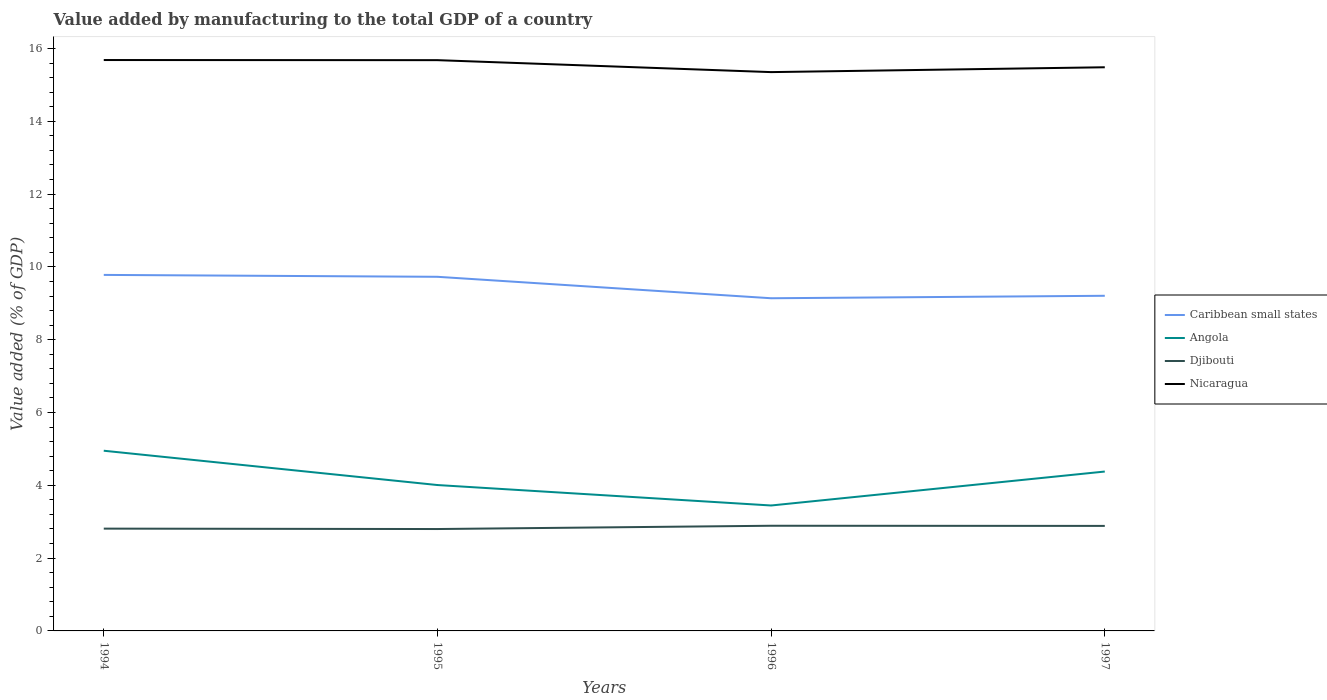Does the line corresponding to Nicaragua intersect with the line corresponding to Djibouti?
Make the answer very short. No. Is the number of lines equal to the number of legend labels?
Keep it short and to the point. Yes. Across all years, what is the maximum value added by manufacturing to the total GDP in Nicaragua?
Provide a succinct answer. 15.35. What is the total value added by manufacturing to the total GDP in Nicaragua in the graph?
Give a very brief answer. 0. What is the difference between the highest and the second highest value added by manufacturing to the total GDP in Angola?
Keep it short and to the point. 1.5. What is the difference between the highest and the lowest value added by manufacturing to the total GDP in Angola?
Give a very brief answer. 2. Is the value added by manufacturing to the total GDP in Nicaragua strictly greater than the value added by manufacturing to the total GDP in Angola over the years?
Keep it short and to the point. No. What is the difference between two consecutive major ticks on the Y-axis?
Offer a very short reply. 2. Are the values on the major ticks of Y-axis written in scientific E-notation?
Your response must be concise. No. Does the graph contain grids?
Keep it short and to the point. No. Where does the legend appear in the graph?
Give a very brief answer. Center right. How many legend labels are there?
Keep it short and to the point. 4. How are the legend labels stacked?
Your answer should be compact. Vertical. What is the title of the graph?
Provide a succinct answer. Value added by manufacturing to the total GDP of a country. What is the label or title of the Y-axis?
Make the answer very short. Value added (% of GDP). What is the Value added (% of GDP) of Caribbean small states in 1994?
Give a very brief answer. 9.78. What is the Value added (% of GDP) of Angola in 1994?
Your answer should be very brief. 4.95. What is the Value added (% of GDP) of Djibouti in 1994?
Offer a very short reply. 2.81. What is the Value added (% of GDP) in Nicaragua in 1994?
Your answer should be very brief. 15.68. What is the Value added (% of GDP) in Caribbean small states in 1995?
Your answer should be compact. 9.73. What is the Value added (% of GDP) in Angola in 1995?
Your response must be concise. 4.01. What is the Value added (% of GDP) in Djibouti in 1995?
Keep it short and to the point. 2.8. What is the Value added (% of GDP) in Nicaragua in 1995?
Ensure brevity in your answer.  15.68. What is the Value added (% of GDP) in Caribbean small states in 1996?
Your answer should be very brief. 9.14. What is the Value added (% of GDP) in Angola in 1996?
Make the answer very short. 3.45. What is the Value added (% of GDP) in Djibouti in 1996?
Your response must be concise. 2.89. What is the Value added (% of GDP) in Nicaragua in 1996?
Offer a terse response. 15.35. What is the Value added (% of GDP) of Caribbean small states in 1997?
Your answer should be very brief. 9.21. What is the Value added (% of GDP) of Angola in 1997?
Your answer should be compact. 4.38. What is the Value added (% of GDP) of Djibouti in 1997?
Provide a short and direct response. 2.89. What is the Value added (% of GDP) in Nicaragua in 1997?
Provide a short and direct response. 15.48. Across all years, what is the maximum Value added (% of GDP) of Caribbean small states?
Offer a very short reply. 9.78. Across all years, what is the maximum Value added (% of GDP) in Angola?
Provide a short and direct response. 4.95. Across all years, what is the maximum Value added (% of GDP) in Djibouti?
Offer a very short reply. 2.89. Across all years, what is the maximum Value added (% of GDP) of Nicaragua?
Provide a short and direct response. 15.68. Across all years, what is the minimum Value added (% of GDP) in Caribbean small states?
Provide a short and direct response. 9.14. Across all years, what is the minimum Value added (% of GDP) in Angola?
Offer a terse response. 3.45. Across all years, what is the minimum Value added (% of GDP) of Djibouti?
Offer a very short reply. 2.8. Across all years, what is the minimum Value added (% of GDP) in Nicaragua?
Provide a short and direct response. 15.35. What is the total Value added (% of GDP) of Caribbean small states in the graph?
Make the answer very short. 37.85. What is the total Value added (% of GDP) of Angola in the graph?
Your response must be concise. 16.78. What is the total Value added (% of GDP) of Djibouti in the graph?
Provide a short and direct response. 11.38. What is the total Value added (% of GDP) of Nicaragua in the graph?
Provide a succinct answer. 62.2. What is the difference between the Value added (% of GDP) in Caribbean small states in 1994 and that in 1995?
Your answer should be compact. 0.05. What is the difference between the Value added (% of GDP) in Angola in 1994 and that in 1995?
Make the answer very short. 0.94. What is the difference between the Value added (% of GDP) in Djibouti in 1994 and that in 1995?
Provide a succinct answer. 0.01. What is the difference between the Value added (% of GDP) of Nicaragua in 1994 and that in 1995?
Ensure brevity in your answer.  0. What is the difference between the Value added (% of GDP) in Caribbean small states in 1994 and that in 1996?
Ensure brevity in your answer.  0.64. What is the difference between the Value added (% of GDP) in Angola in 1994 and that in 1996?
Keep it short and to the point. 1.5. What is the difference between the Value added (% of GDP) of Djibouti in 1994 and that in 1996?
Provide a short and direct response. -0.08. What is the difference between the Value added (% of GDP) of Nicaragua in 1994 and that in 1996?
Keep it short and to the point. 0.33. What is the difference between the Value added (% of GDP) in Caribbean small states in 1994 and that in 1997?
Your answer should be compact. 0.57. What is the difference between the Value added (% of GDP) in Angola in 1994 and that in 1997?
Your answer should be very brief. 0.57. What is the difference between the Value added (% of GDP) of Djibouti in 1994 and that in 1997?
Make the answer very short. -0.07. What is the difference between the Value added (% of GDP) in Nicaragua in 1994 and that in 1997?
Your answer should be compact. 0.2. What is the difference between the Value added (% of GDP) in Caribbean small states in 1995 and that in 1996?
Your answer should be very brief. 0.59. What is the difference between the Value added (% of GDP) in Angola in 1995 and that in 1996?
Ensure brevity in your answer.  0.56. What is the difference between the Value added (% of GDP) in Djibouti in 1995 and that in 1996?
Ensure brevity in your answer.  -0.09. What is the difference between the Value added (% of GDP) in Nicaragua in 1995 and that in 1996?
Offer a very short reply. 0.33. What is the difference between the Value added (% of GDP) of Caribbean small states in 1995 and that in 1997?
Provide a succinct answer. 0.52. What is the difference between the Value added (% of GDP) in Angola in 1995 and that in 1997?
Give a very brief answer. -0.37. What is the difference between the Value added (% of GDP) of Djibouti in 1995 and that in 1997?
Keep it short and to the point. -0.09. What is the difference between the Value added (% of GDP) of Nicaragua in 1995 and that in 1997?
Your response must be concise. 0.2. What is the difference between the Value added (% of GDP) of Caribbean small states in 1996 and that in 1997?
Your answer should be very brief. -0.07. What is the difference between the Value added (% of GDP) of Angola in 1996 and that in 1997?
Your answer should be compact. -0.93. What is the difference between the Value added (% of GDP) of Djibouti in 1996 and that in 1997?
Your response must be concise. 0. What is the difference between the Value added (% of GDP) of Nicaragua in 1996 and that in 1997?
Provide a succinct answer. -0.13. What is the difference between the Value added (% of GDP) of Caribbean small states in 1994 and the Value added (% of GDP) of Angola in 1995?
Give a very brief answer. 5.77. What is the difference between the Value added (% of GDP) of Caribbean small states in 1994 and the Value added (% of GDP) of Djibouti in 1995?
Your answer should be very brief. 6.98. What is the difference between the Value added (% of GDP) of Caribbean small states in 1994 and the Value added (% of GDP) of Nicaragua in 1995?
Keep it short and to the point. -5.9. What is the difference between the Value added (% of GDP) of Angola in 1994 and the Value added (% of GDP) of Djibouti in 1995?
Offer a terse response. 2.15. What is the difference between the Value added (% of GDP) in Angola in 1994 and the Value added (% of GDP) in Nicaragua in 1995?
Provide a succinct answer. -10.73. What is the difference between the Value added (% of GDP) of Djibouti in 1994 and the Value added (% of GDP) of Nicaragua in 1995?
Make the answer very short. -12.87. What is the difference between the Value added (% of GDP) of Caribbean small states in 1994 and the Value added (% of GDP) of Angola in 1996?
Your answer should be very brief. 6.33. What is the difference between the Value added (% of GDP) of Caribbean small states in 1994 and the Value added (% of GDP) of Djibouti in 1996?
Give a very brief answer. 6.89. What is the difference between the Value added (% of GDP) in Caribbean small states in 1994 and the Value added (% of GDP) in Nicaragua in 1996?
Your response must be concise. -5.57. What is the difference between the Value added (% of GDP) in Angola in 1994 and the Value added (% of GDP) in Djibouti in 1996?
Your answer should be compact. 2.06. What is the difference between the Value added (% of GDP) of Angola in 1994 and the Value added (% of GDP) of Nicaragua in 1996?
Keep it short and to the point. -10.4. What is the difference between the Value added (% of GDP) of Djibouti in 1994 and the Value added (% of GDP) of Nicaragua in 1996?
Keep it short and to the point. -12.54. What is the difference between the Value added (% of GDP) in Caribbean small states in 1994 and the Value added (% of GDP) in Angola in 1997?
Your answer should be very brief. 5.4. What is the difference between the Value added (% of GDP) of Caribbean small states in 1994 and the Value added (% of GDP) of Djibouti in 1997?
Provide a short and direct response. 6.89. What is the difference between the Value added (% of GDP) in Caribbean small states in 1994 and the Value added (% of GDP) in Nicaragua in 1997?
Offer a terse response. -5.7. What is the difference between the Value added (% of GDP) in Angola in 1994 and the Value added (% of GDP) in Djibouti in 1997?
Provide a succinct answer. 2.06. What is the difference between the Value added (% of GDP) in Angola in 1994 and the Value added (% of GDP) in Nicaragua in 1997?
Give a very brief answer. -10.53. What is the difference between the Value added (% of GDP) in Djibouti in 1994 and the Value added (% of GDP) in Nicaragua in 1997?
Make the answer very short. -12.67. What is the difference between the Value added (% of GDP) in Caribbean small states in 1995 and the Value added (% of GDP) in Angola in 1996?
Your response must be concise. 6.28. What is the difference between the Value added (% of GDP) of Caribbean small states in 1995 and the Value added (% of GDP) of Djibouti in 1996?
Offer a very short reply. 6.84. What is the difference between the Value added (% of GDP) of Caribbean small states in 1995 and the Value added (% of GDP) of Nicaragua in 1996?
Offer a very short reply. -5.62. What is the difference between the Value added (% of GDP) in Angola in 1995 and the Value added (% of GDP) in Djibouti in 1996?
Your answer should be compact. 1.12. What is the difference between the Value added (% of GDP) in Angola in 1995 and the Value added (% of GDP) in Nicaragua in 1996?
Your answer should be very brief. -11.34. What is the difference between the Value added (% of GDP) of Djibouti in 1995 and the Value added (% of GDP) of Nicaragua in 1996?
Your response must be concise. -12.55. What is the difference between the Value added (% of GDP) in Caribbean small states in 1995 and the Value added (% of GDP) in Angola in 1997?
Offer a very short reply. 5.35. What is the difference between the Value added (% of GDP) in Caribbean small states in 1995 and the Value added (% of GDP) in Djibouti in 1997?
Provide a succinct answer. 6.84. What is the difference between the Value added (% of GDP) of Caribbean small states in 1995 and the Value added (% of GDP) of Nicaragua in 1997?
Your answer should be compact. -5.76. What is the difference between the Value added (% of GDP) of Angola in 1995 and the Value added (% of GDP) of Djibouti in 1997?
Keep it short and to the point. 1.12. What is the difference between the Value added (% of GDP) in Angola in 1995 and the Value added (% of GDP) in Nicaragua in 1997?
Your response must be concise. -11.48. What is the difference between the Value added (% of GDP) of Djibouti in 1995 and the Value added (% of GDP) of Nicaragua in 1997?
Provide a short and direct response. -12.69. What is the difference between the Value added (% of GDP) in Caribbean small states in 1996 and the Value added (% of GDP) in Angola in 1997?
Your answer should be very brief. 4.76. What is the difference between the Value added (% of GDP) of Caribbean small states in 1996 and the Value added (% of GDP) of Djibouti in 1997?
Your answer should be compact. 6.25. What is the difference between the Value added (% of GDP) of Caribbean small states in 1996 and the Value added (% of GDP) of Nicaragua in 1997?
Make the answer very short. -6.35. What is the difference between the Value added (% of GDP) in Angola in 1996 and the Value added (% of GDP) in Djibouti in 1997?
Offer a very short reply. 0.56. What is the difference between the Value added (% of GDP) in Angola in 1996 and the Value added (% of GDP) in Nicaragua in 1997?
Your answer should be compact. -12.04. What is the difference between the Value added (% of GDP) of Djibouti in 1996 and the Value added (% of GDP) of Nicaragua in 1997?
Offer a very short reply. -12.6. What is the average Value added (% of GDP) in Caribbean small states per year?
Provide a succinct answer. 9.46. What is the average Value added (% of GDP) of Angola per year?
Provide a short and direct response. 4.2. What is the average Value added (% of GDP) of Djibouti per year?
Give a very brief answer. 2.85. What is the average Value added (% of GDP) in Nicaragua per year?
Provide a short and direct response. 15.55. In the year 1994, what is the difference between the Value added (% of GDP) of Caribbean small states and Value added (% of GDP) of Angola?
Your answer should be compact. 4.83. In the year 1994, what is the difference between the Value added (% of GDP) of Caribbean small states and Value added (% of GDP) of Djibouti?
Make the answer very short. 6.97. In the year 1994, what is the difference between the Value added (% of GDP) in Caribbean small states and Value added (% of GDP) in Nicaragua?
Your response must be concise. -5.9. In the year 1994, what is the difference between the Value added (% of GDP) of Angola and Value added (% of GDP) of Djibouti?
Your answer should be very brief. 2.14. In the year 1994, what is the difference between the Value added (% of GDP) in Angola and Value added (% of GDP) in Nicaragua?
Ensure brevity in your answer.  -10.73. In the year 1994, what is the difference between the Value added (% of GDP) of Djibouti and Value added (% of GDP) of Nicaragua?
Keep it short and to the point. -12.87. In the year 1995, what is the difference between the Value added (% of GDP) in Caribbean small states and Value added (% of GDP) in Angola?
Offer a very short reply. 5.72. In the year 1995, what is the difference between the Value added (% of GDP) of Caribbean small states and Value added (% of GDP) of Djibouti?
Give a very brief answer. 6.93. In the year 1995, what is the difference between the Value added (% of GDP) of Caribbean small states and Value added (% of GDP) of Nicaragua?
Offer a very short reply. -5.95. In the year 1995, what is the difference between the Value added (% of GDP) in Angola and Value added (% of GDP) in Djibouti?
Make the answer very short. 1.21. In the year 1995, what is the difference between the Value added (% of GDP) of Angola and Value added (% of GDP) of Nicaragua?
Your answer should be very brief. -11.67. In the year 1995, what is the difference between the Value added (% of GDP) in Djibouti and Value added (% of GDP) in Nicaragua?
Make the answer very short. -12.88. In the year 1996, what is the difference between the Value added (% of GDP) of Caribbean small states and Value added (% of GDP) of Angola?
Your response must be concise. 5.69. In the year 1996, what is the difference between the Value added (% of GDP) in Caribbean small states and Value added (% of GDP) in Djibouti?
Give a very brief answer. 6.25. In the year 1996, what is the difference between the Value added (% of GDP) in Caribbean small states and Value added (% of GDP) in Nicaragua?
Make the answer very short. -6.21. In the year 1996, what is the difference between the Value added (% of GDP) of Angola and Value added (% of GDP) of Djibouti?
Ensure brevity in your answer.  0.56. In the year 1996, what is the difference between the Value added (% of GDP) in Angola and Value added (% of GDP) in Nicaragua?
Give a very brief answer. -11.91. In the year 1996, what is the difference between the Value added (% of GDP) of Djibouti and Value added (% of GDP) of Nicaragua?
Make the answer very short. -12.46. In the year 1997, what is the difference between the Value added (% of GDP) of Caribbean small states and Value added (% of GDP) of Angola?
Provide a succinct answer. 4.83. In the year 1997, what is the difference between the Value added (% of GDP) of Caribbean small states and Value added (% of GDP) of Djibouti?
Offer a terse response. 6.32. In the year 1997, what is the difference between the Value added (% of GDP) of Caribbean small states and Value added (% of GDP) of Nicaragua?
Provide a short and direct response. -6.28. In the year 1997, what is the difference between the Value added (% of GDP) of Angola and Value added (% of GDP) of Djibouti?
Offer a very short reply. 1.49. In the year 1997, what is the difference between the Value added (% of GDP) of Angola and Value added (% of GDP) of Nicaragua?
Give a very brief answer. -11.11. In the year 1997, what is the difference between the Value added (% of GDP) of Djibouti and Value added (% of GDP) of Nicaragua?
Keep it short and to the point. -12.6. What is the ratio of the Value added (% of GDP) in Caribbean small states in 1994 to that in 1995?
Provide a succinct answer. 1.01. What is the ratio of the Value added (% of GDP) of Angola in 1994 to that in 1995?
Give a very brief answer. 1.24. What is the ratio of the Value added (% of GDP) in Caribbean small states in 1994 to that in 1996?
Provide a succinct answer. 1.07. What is the ratio of the Value added (% of GDP) of Angola in 1994 to that in 1996?
Offer a very short reply. 1.44. What is the ratio of the Value added (% of GDP) in Djibouti in 1994 to that in 1996?
Your answer should be compact. 0.97. What is the ratio of the Value added (% of GDP) of Nicaragua in 1994 to that in 1996?
Offer a terse response. 1.02. What is the ratio of the Value added (% of GDP) of Caribbean small states in 1994 to that in 1997?
Offer a terse response. 1.06. What is the ratio of the Value added (% of GDP) in Angola in 1994 to that in 1997?
Your answer should be very brief. 1.13. What is the ratio of the Value added (% of GDP) of Djibouti in 1994 to that in 1997?
Provide a succinct answer. 0.97. What is the ratio of the Value added (% of GDP) of Nicaragua in 1994 to that in 1997?
Make the answer very short. 1.01. What is the ratio of the Value added (% of GDP) in Caribbean small states in 1995 to that in 1996?
Offer a terse response. 1.06. What is the ratio of the Value added (% of GDP) of Angola in 1995 to that in 1996?
Provide a short and direct response. 1.16. What is the ratio of the Value added (% of GDP) of Djibouti in 1995 to that in 1996?
Keep it short and to the point. 0.97. What is the ratio of the Value added (% of GDP) in Nicaragua in 1995 to that in 1996?
Offer a terse response. 1.02. What is the ratio of the Value added (% of GDP) of Caribbean small states in 1995 to that in 1997?
Make the answer very short. 1.06. What is the ratio of the Value added (% of GDP) of Angola in 1995 to that in 1997?
Give a very brief answer. 0.92. What is the ratio of the Value added (% of GDP) of Djibouti in 1995 to that in 1997?
Give a very brief answer. 0.97. What is the ratio of the Value added (% of GDP) in Nicaragua in 1995 to that in 1997?
Offer a terse response. 1.01. What is the ratio of the Value added (% of GDP) in Angola in 1996 to that in 1997?
Offer a terse response. 0.79. What is the ratio of the Value added (% of GDP) in Djibouti in 1996 to that in 1997?
Provide a succinct answer. 1. What is the difference between the highest and the second highest Value added (% of GDP) in Caribbean small states?
Your answer should be very brief. 0.05. What is the difference between the highest and the second highest Value added (% of GDP) in Angola?
Provide a succinct answer. 0.57. What is the difference between the highest and the second highest Value added (% of GDP) of Djibouti?
Provide a succinct answer. 0. What is the difference between the highest and the second highest Value added (% of GDP) of Nicaragua?
Offer a terse response. 0. What is the difference between the highest and the lowest Value added (% of GDP) in Caribbean small states?
Your answer should be compact. 0.64. What is the difference between the highest and the lowest Value added (% of GDP) of Angola?
Your response must be concise. 1.5. What is the difference between the highest and the lowest Value added (% of GDP) in Djibouti?
Give a very brief answer. 0.09. What is the difference between the highest and the lowest Value added (% of GDP) in Nicaragua?
Provide a short and direct response. 0.33. 